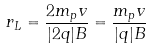Convert formula to latex. <formula><loc_0><loc_0><loc_500><loc_500>r _ { L } = \frac { 2 m _ { p } v } { | 2 q | B } = \frac { m _ { p } v } { | q | B }</formula> 